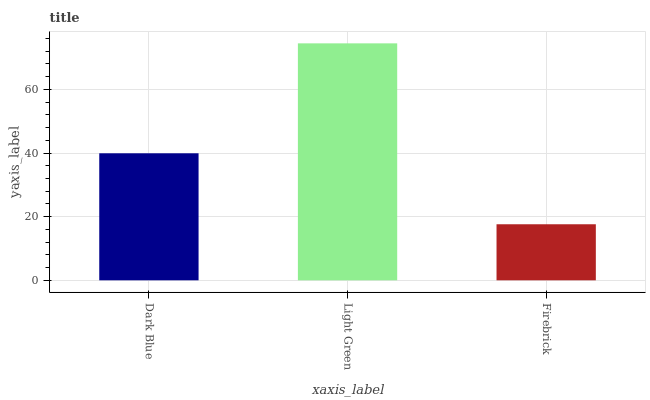Is Firebrick the minimum?
Answer yes or no. Yes. Is Light Green the maximum?
Answer yes or no. Yes. Is Light Green the minimum?
Answer yes or no. No. Is Firebrick the maximum?
Answer yes or no. No. Is Light Green greater than Firebrick?
Answer yes or no. Yes. Is Firebrick less than Light Green?
Answer yes or no. Yes. Is Firebrick greater than Light Green?
Answer yes or no. No. Is Light Green less than Firebrick?
Answer yes or no. No. Is Dark Blue the high median?
Answer yes or no. Yes. Is Dark Blue the low median?
Answer yes or no. Yes. Is Light Green the high median?
Answer yes or no. No. Is Firebrick the low median?
Answer yes or no. No. 